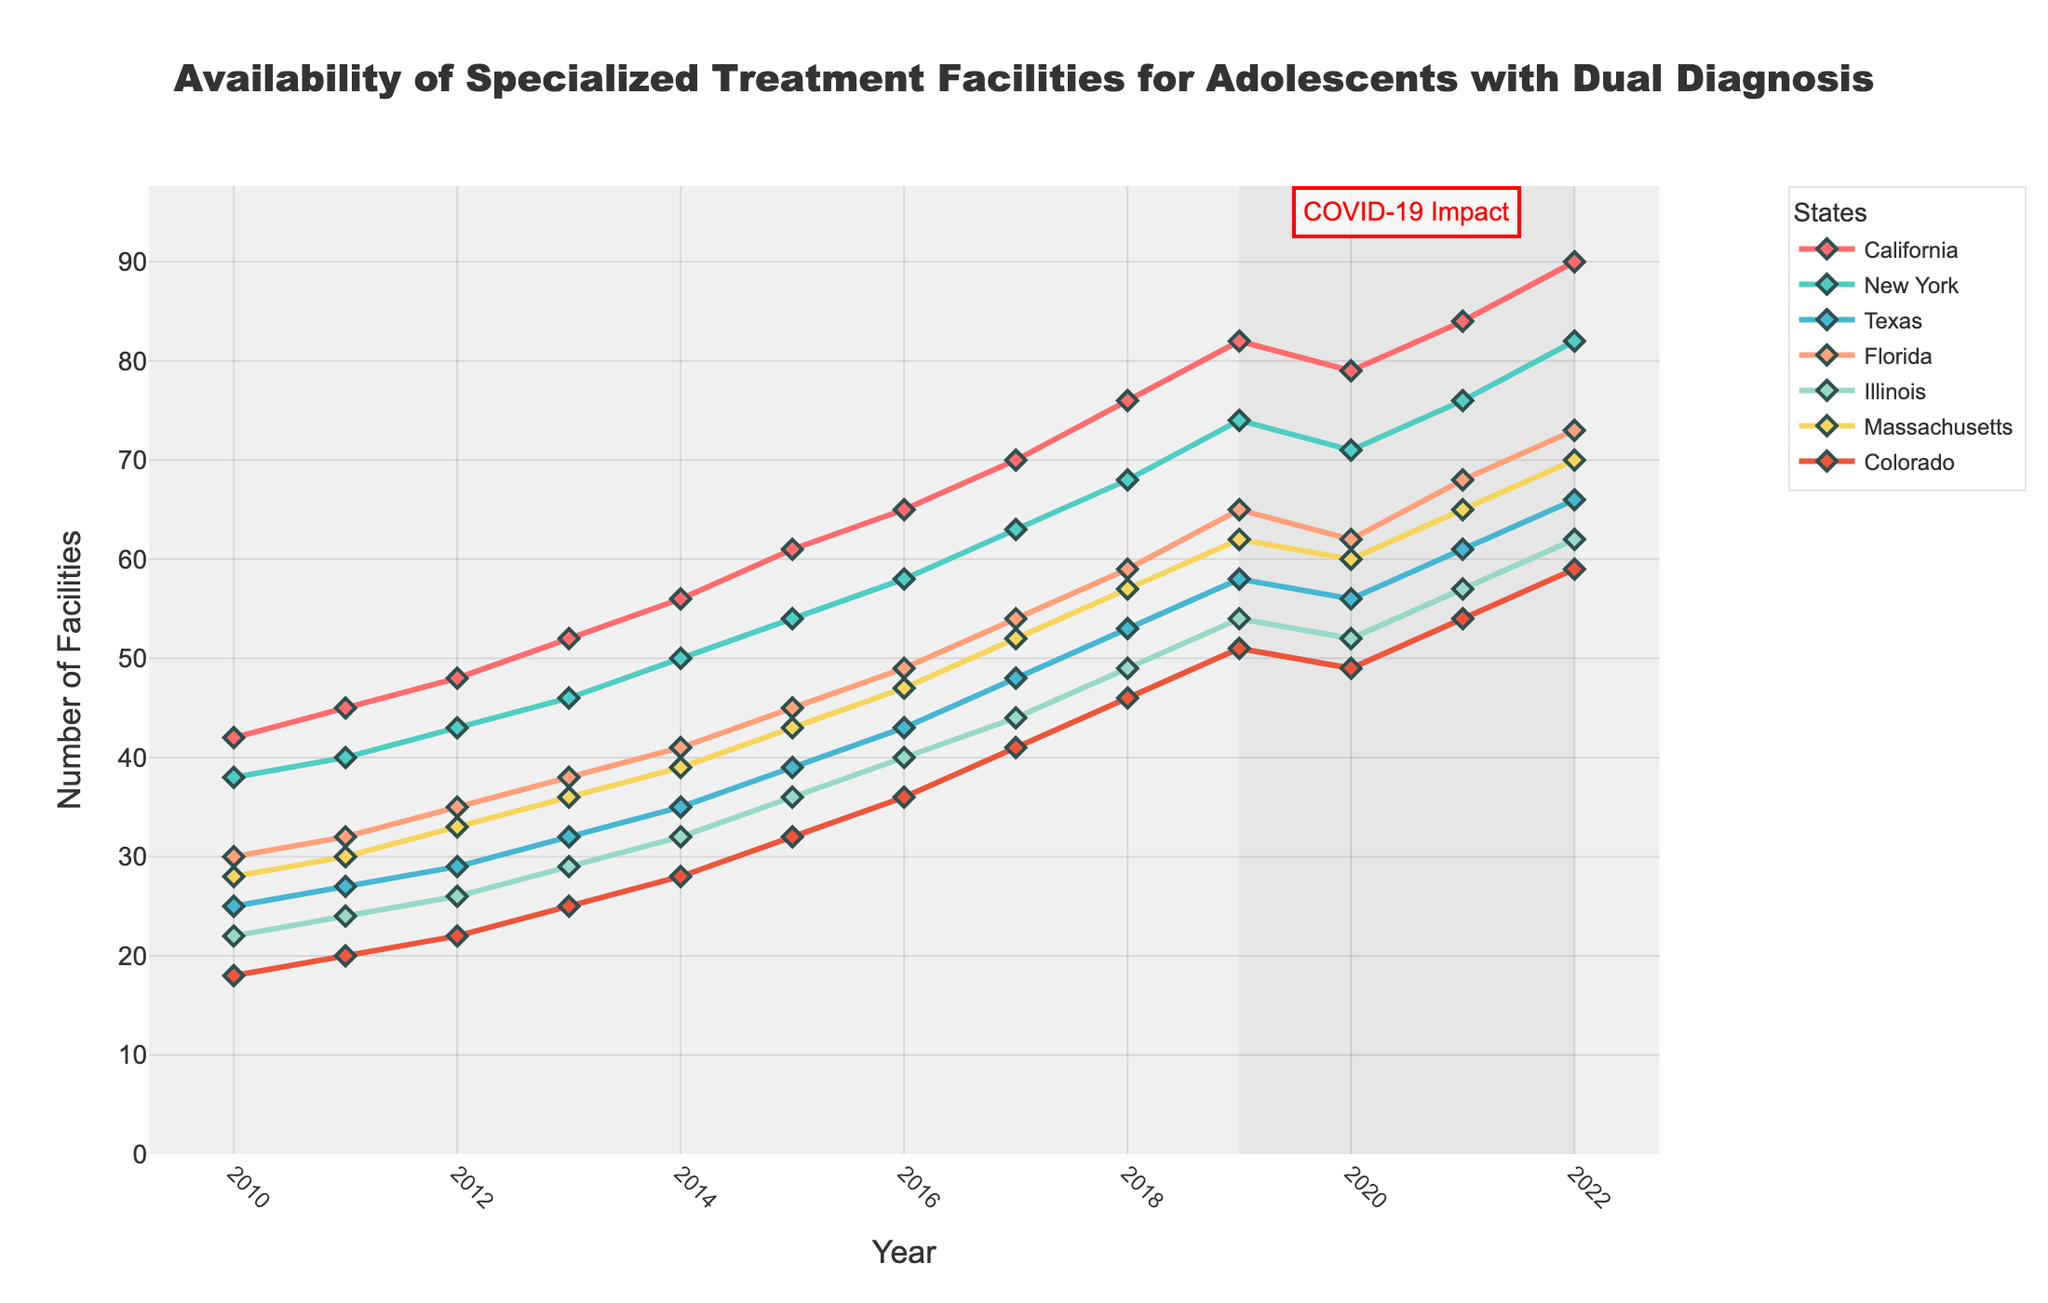Which state had the highest number of specialized treatment facilities in 2022? Look at the data points for 2022 across all states. The highest value is in California with 90 facilities.
Answer: California Which state saw the largest increase in the number of facilities from 2010 to 2022? Calculate the difference between 2022 and 2010 for each state. The largest increase is in California (90 - 42 = 48).
Answer: California During the period shaded for the COVID-19 impact, did any state show a decrease in facilities? If so, which state? Observe the data points from 2019 to 2020. California shows a decrease from 82 to 79.
Answer: California Comparing Texas and Florida, which state had more facilities in 2015? Look at the 2015 values for both Texas and Florida. Texas had 39, while Florida had 45.
Answer: Florida What was the average number of facilities in Colorado from 2010 to 2022? Sum the number of facilities in Colorado from 2010 to 2022 and divide by the number of years (18 + 20 + 22 + 25 + 28 + 32 + 36 + 41 + 46 + 51 + 49 + 54 + 59) / 13 = 36.
Answer: 36 Which states had more than 50 facilities in 2020? Look at the 2020 data for all states. New York, Texas, Florida, and California had more than 50 facilities.
Answer: New York, Texas, Florida, California During which years did Illinois have a consistent increase in the number of facilities? Observe the data points for Illinois year by year. Illinois increased consistently from 2010 to 2022.
Answer: 2010-2022 How many more facilities did Massachusetts have in 2022 compared to 2010? Subtract the 2010 value for Massachusetts from the 2022 value (70 - 28 = 42).
Answer: 42 What is the trend in the number of facilities in New York from 2018 to 2022? Observe the data points for New York from 2018 to 2022. It's an increasing trend from 68 to 82.
Answer: Increasing Between 2019 and 2020, did any states experience a decrease in the number of facilities? Review each state’s data between 2019 and 2020. California, New York, Texas, Florida, and Illinois all show a decrease.
Answer: California, New York, Texas, Florida, Illinois 